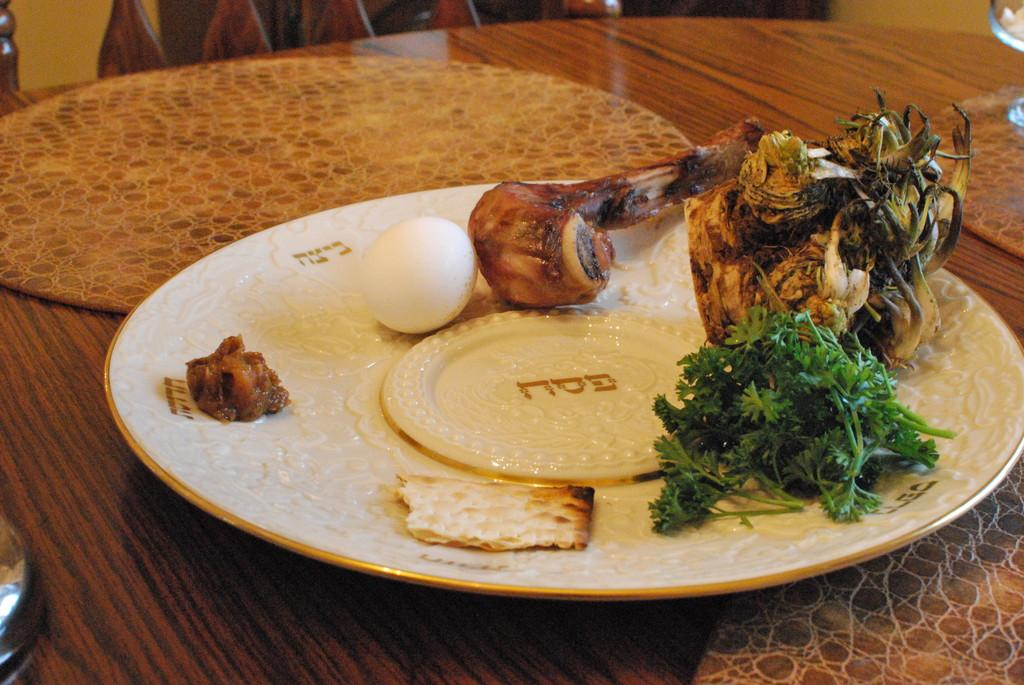What piece of furniture is visible in the image? There is a table in the image. What is placed on the table? There is a plate on the table. What is on the plate? There is food on the plate, including an egg and mint leaves. Can you tell me how many women are crying in the image? There are no women or crying depicted in the image; it features a table with a plate of food. 